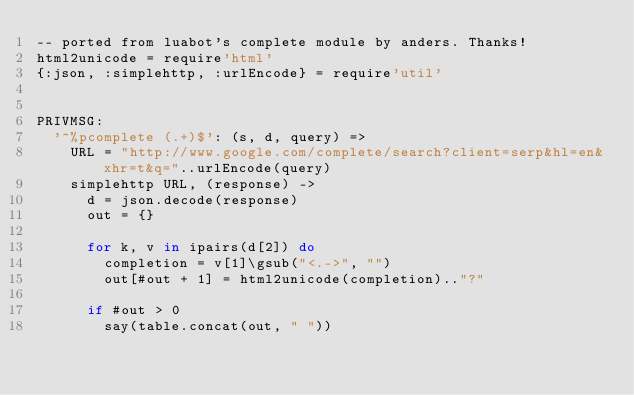<code> <loc_0><loc_0><loc_500><loc_500><_MoonScript_>-- ported from luabot's complete module by anders. Thanks!
html2unicode = require'html'
{:json, :simplehttp, :urlEncode} = require'util'


PRIVMSG:
  '^%pcomplete (.+)$': (s, d, query) =>
    URL = "http://www.google.com/complete/search?client=serp&hl=en&xhr=t&q="..urlEncode(query)
    simplehttp URL, (response) ->
      d = json.decode(response)
      out = {}

      for k, v in ipairs(d[2]) do
        completion = v[1]\gsub("<.->", "")
        out[#out + 1] = html2unicode(completion).."?"

      if #out > 0
        say(table.concat(out, " "))
</code> 